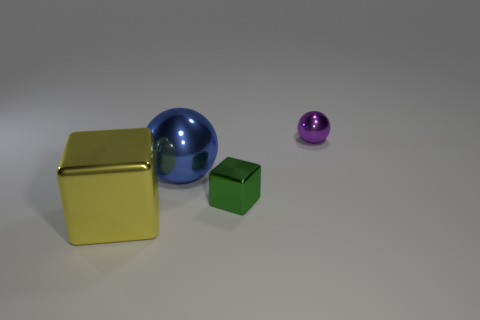There is a tiny metallic object that is the same shape as the large blue metal object; what color is it?
Keep it short and to the point. Purple. Do the blue thing and the block that is behind the large yellow metallic block have the same material?
Provide a succinct answer. Yes. What is the shape of the tiny object that is in front of the tiny purple metallic thing right of the tiny metal block?
Keep it short and to the point. Cube. Is the size of the metal cube right of the blue object the same as the large blue shiny object?
Offer a very short reply. No. What number of other things are there of the same shape as the tiny green object?
Ensure brevity in your answer.  1. Is the color of the block right of the blue metallic sphere the same as the large cube?
Offer a very short reply. No. Is there a rubber cube of the same color as the big metal sphere?
Provide a short and direct response. No. There is a small green block; what number of yellow shiny cubes are on the right side of it?
Give a very brief answer. 0. How many other objects are the same size as the purple object?
Provide a succinct answer. 1. Are the block to the right of the large yellow object and the ball that is behind the blue ball made of the same material?
Your answer should be very brief. Yes. 